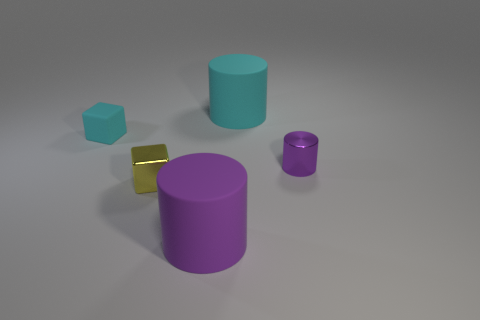What number of purple things are on the left side of the object behind the tiny cyan block?
Provide a succinct answer. 1. Is there a small metallic thing that has the same shape as the large cyan matte object?
Offer a very short reply. Yes. There is a block in front of the cyan matte cube; is it the same size as the matte cylinder in front of the tiny yellow block?
Provide a short and direct response. No. What shape is the big rubber object behind the large matte cylinder in front of the small cyan object?
Your answer should be compact. Cylinder. How many cylinders are the same size as the cyan matte cube?
Your answer should be very brief. 1. Is there a cyan rubber block?
Your response must be concise. Yes. Is there anything else of the same color as the tiny metal block?
Offer a terse response. No. There is a tiny purple object that is made of the same material as the tiny yellow thing; what is its shape?
Provide a short and direct response. Cylinder. What is the color of the large thing that is behind the tiny thing that is on the left side of the small object in front of the tiny purple cylinder?
Your response must be concise. Cyan. Are there the same number of large cyan objects that are to the left of the big cyan object and small purple shiny cylinders?
Offer a terse response. No. 